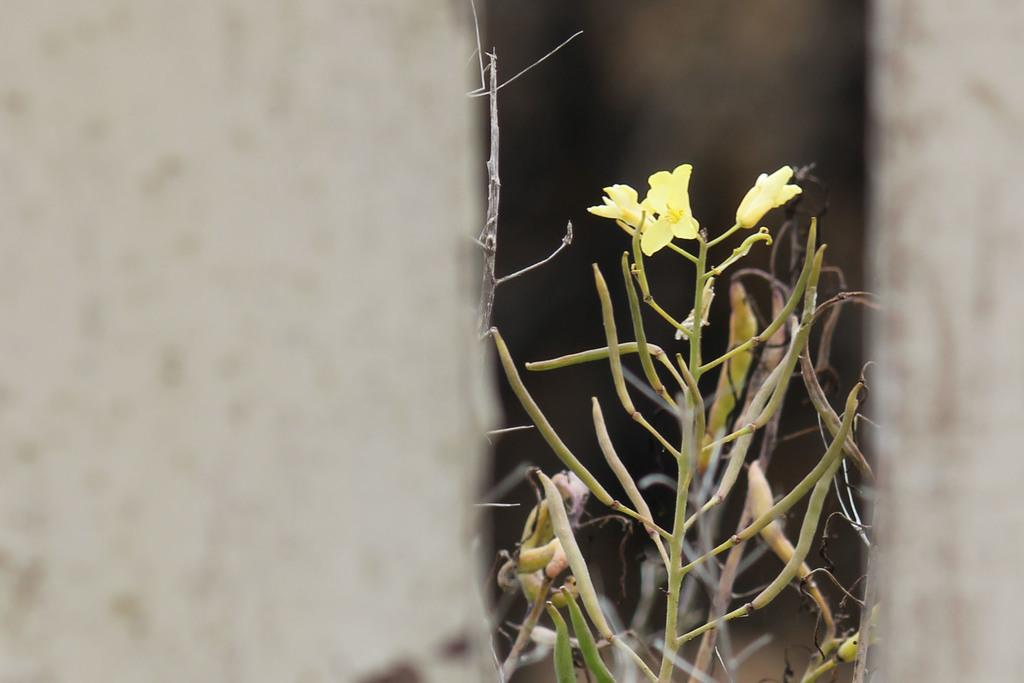What type of living organisms can be seen in the image? Plants can be seen in the image. What is visible in the background of the image? There is a wall in the image. Can you determine the time of day when the image was taken? The image was likely taken during the day, as there is sufficient light to see the plants and wall clearly. What sense is being used by the plants in the image? Plants do not have senses like humans or animals, so this question cannot be answered. 